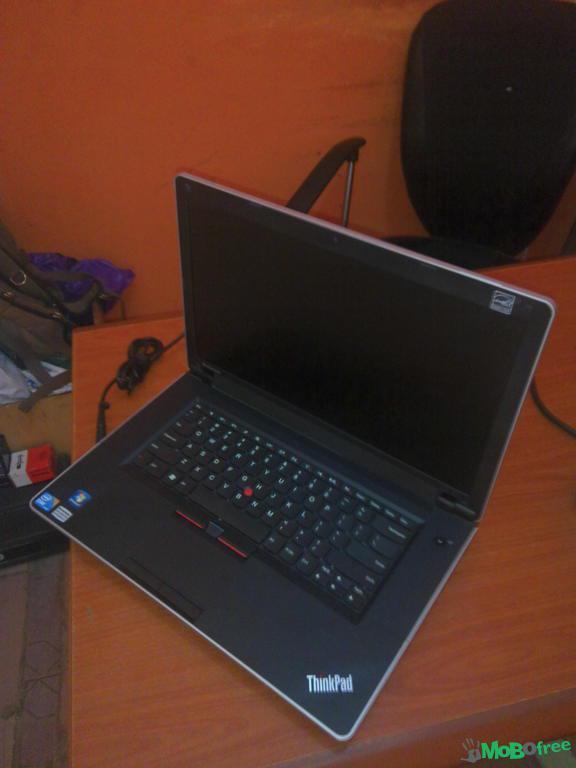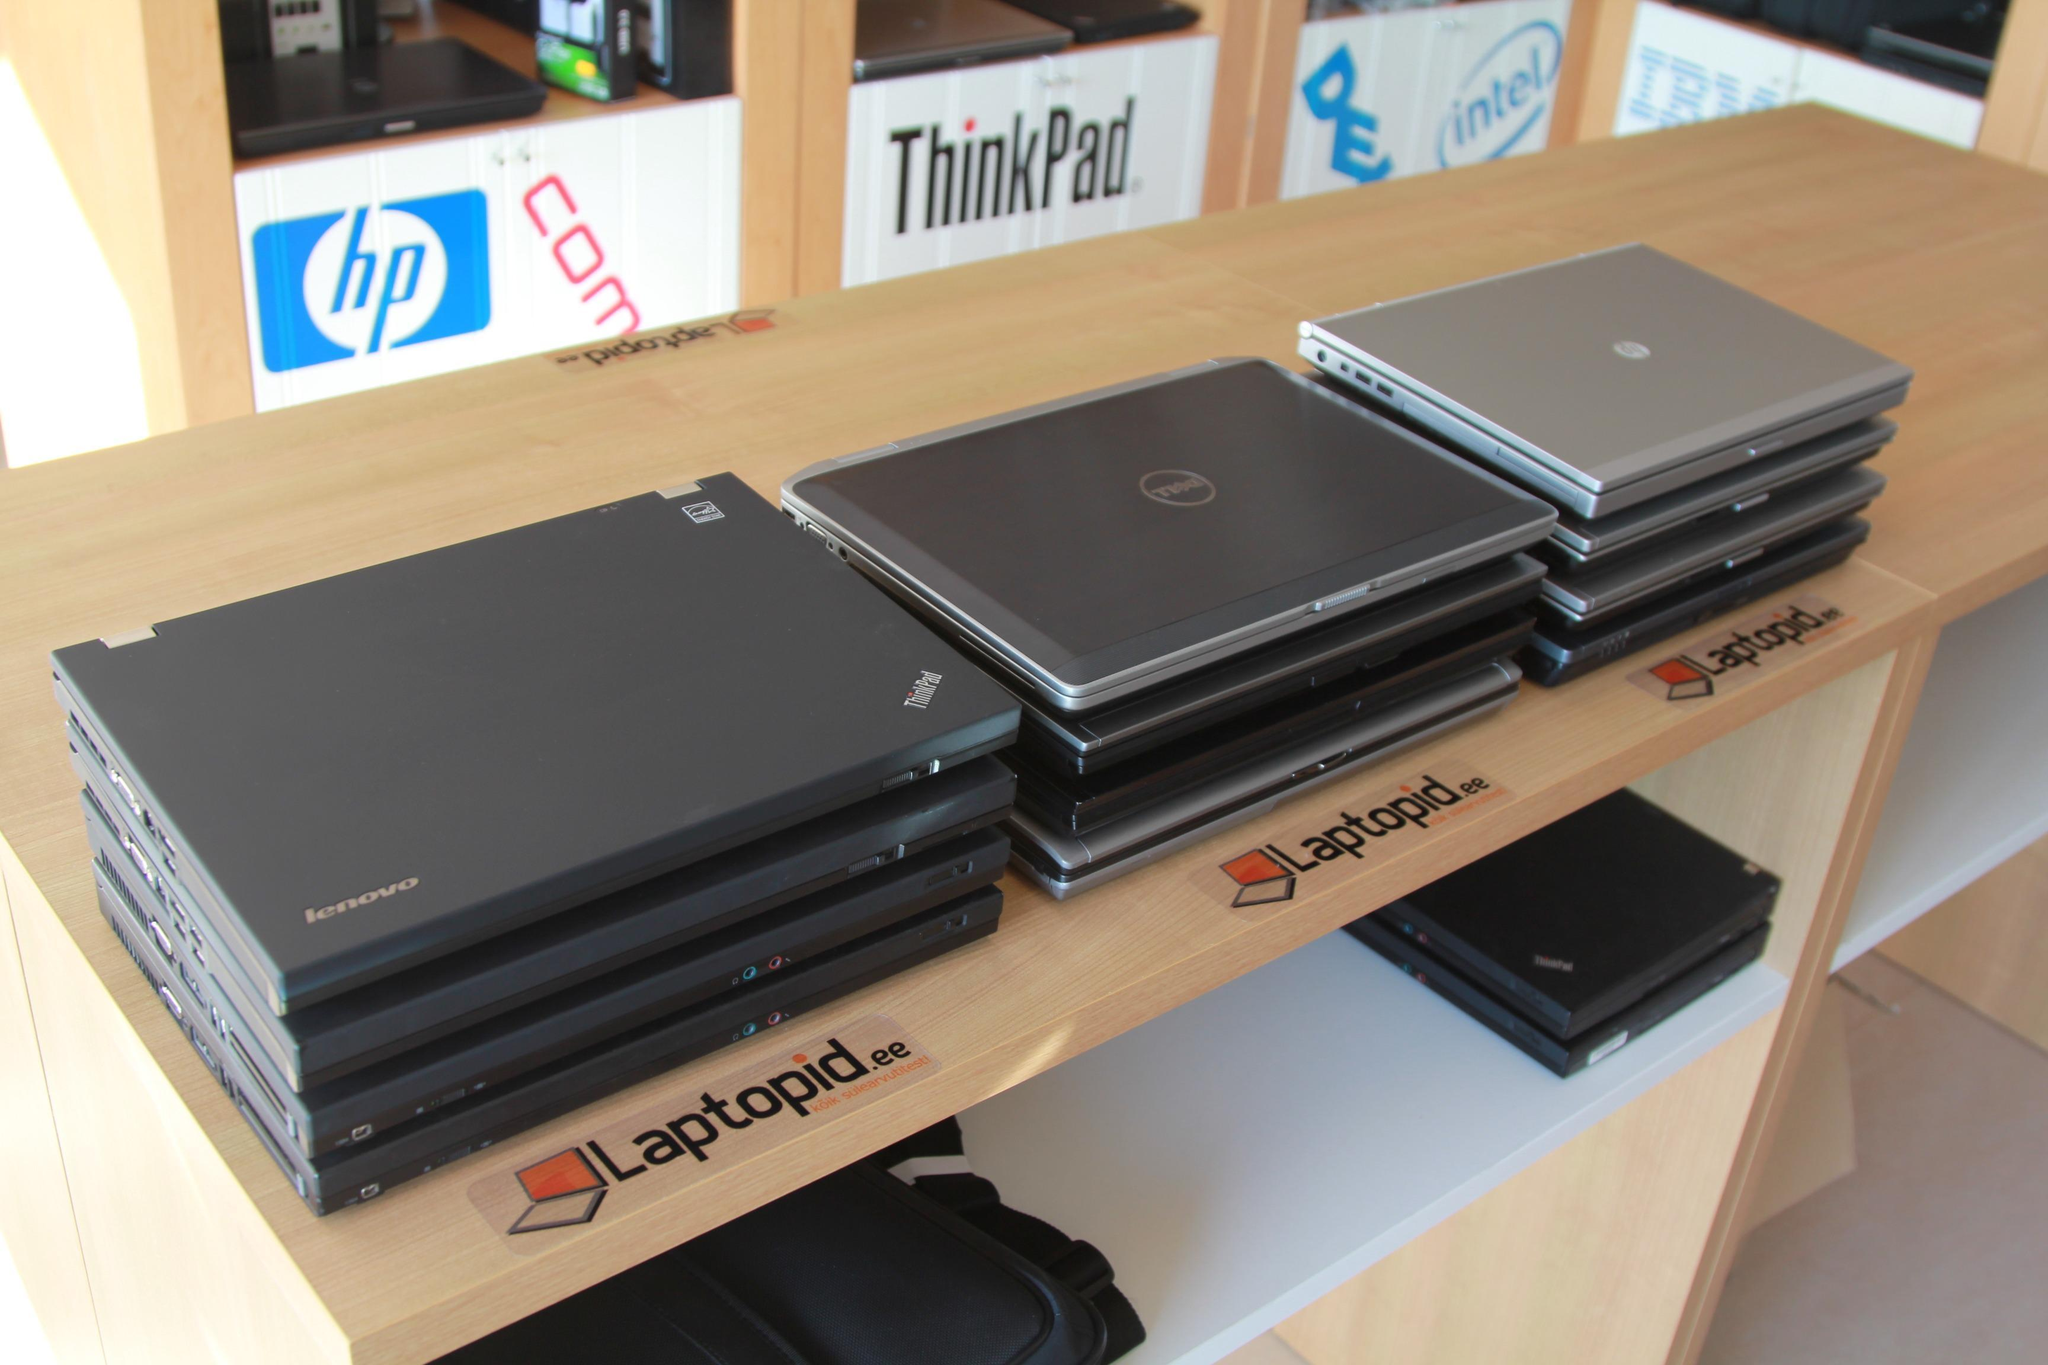The first image is the image on the left, the second image is the image on the right. For the images shown, is this caption "At least one image shows stacks of devices." true? Answer yes or no. Yes. The first image is the image on the left, the second image is the image on the right. Analyze the images presented: Is the assertion "Some laptops are stacked in multiple rows at least four to a stack." valid? Answer yes or no. Yes. 